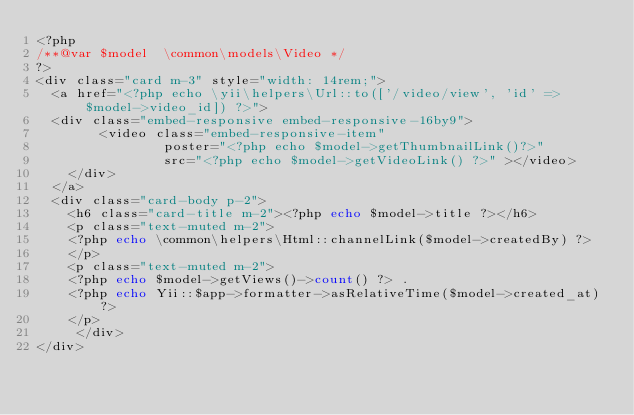Convert code to text. <code><loc_0><loc_0><loc_500><loc_500><_PHP_><?php
/**@var $model  \common\models\Video */
?>
<div class="card m-3" style="width: 14rem;">
  <a href="<?php echo \yii\helpers\Url::to(['/video/view', 'id' => $model->video_id]) ?>">
  <div class="embed-responsive embed-responsive-16by9">
        <video class="embed-responsive-item"
                poster="<?php echo $model->getThumbnailLink()?>"
                src="<?php echo $model->getVideoLink() ?>" ></video>
    </div>
  </a>
  <div class="card-body p-2">
    <h6 class="card-title m-2"><?php echo $model->title ?></h6>
    <p class="text-muted m-2">
    <?php echo \common\helpers\Html::channelLink($model->createdBy) ?>
    </p>
    <p class="text-muted m-2">
    <?php echo $model->getViews()->count() ?> . 
    <?php echo Yii::$app->formatter->asRelativeTime($model->created_at) ?>
    </p>
     </div>
</div></code> 